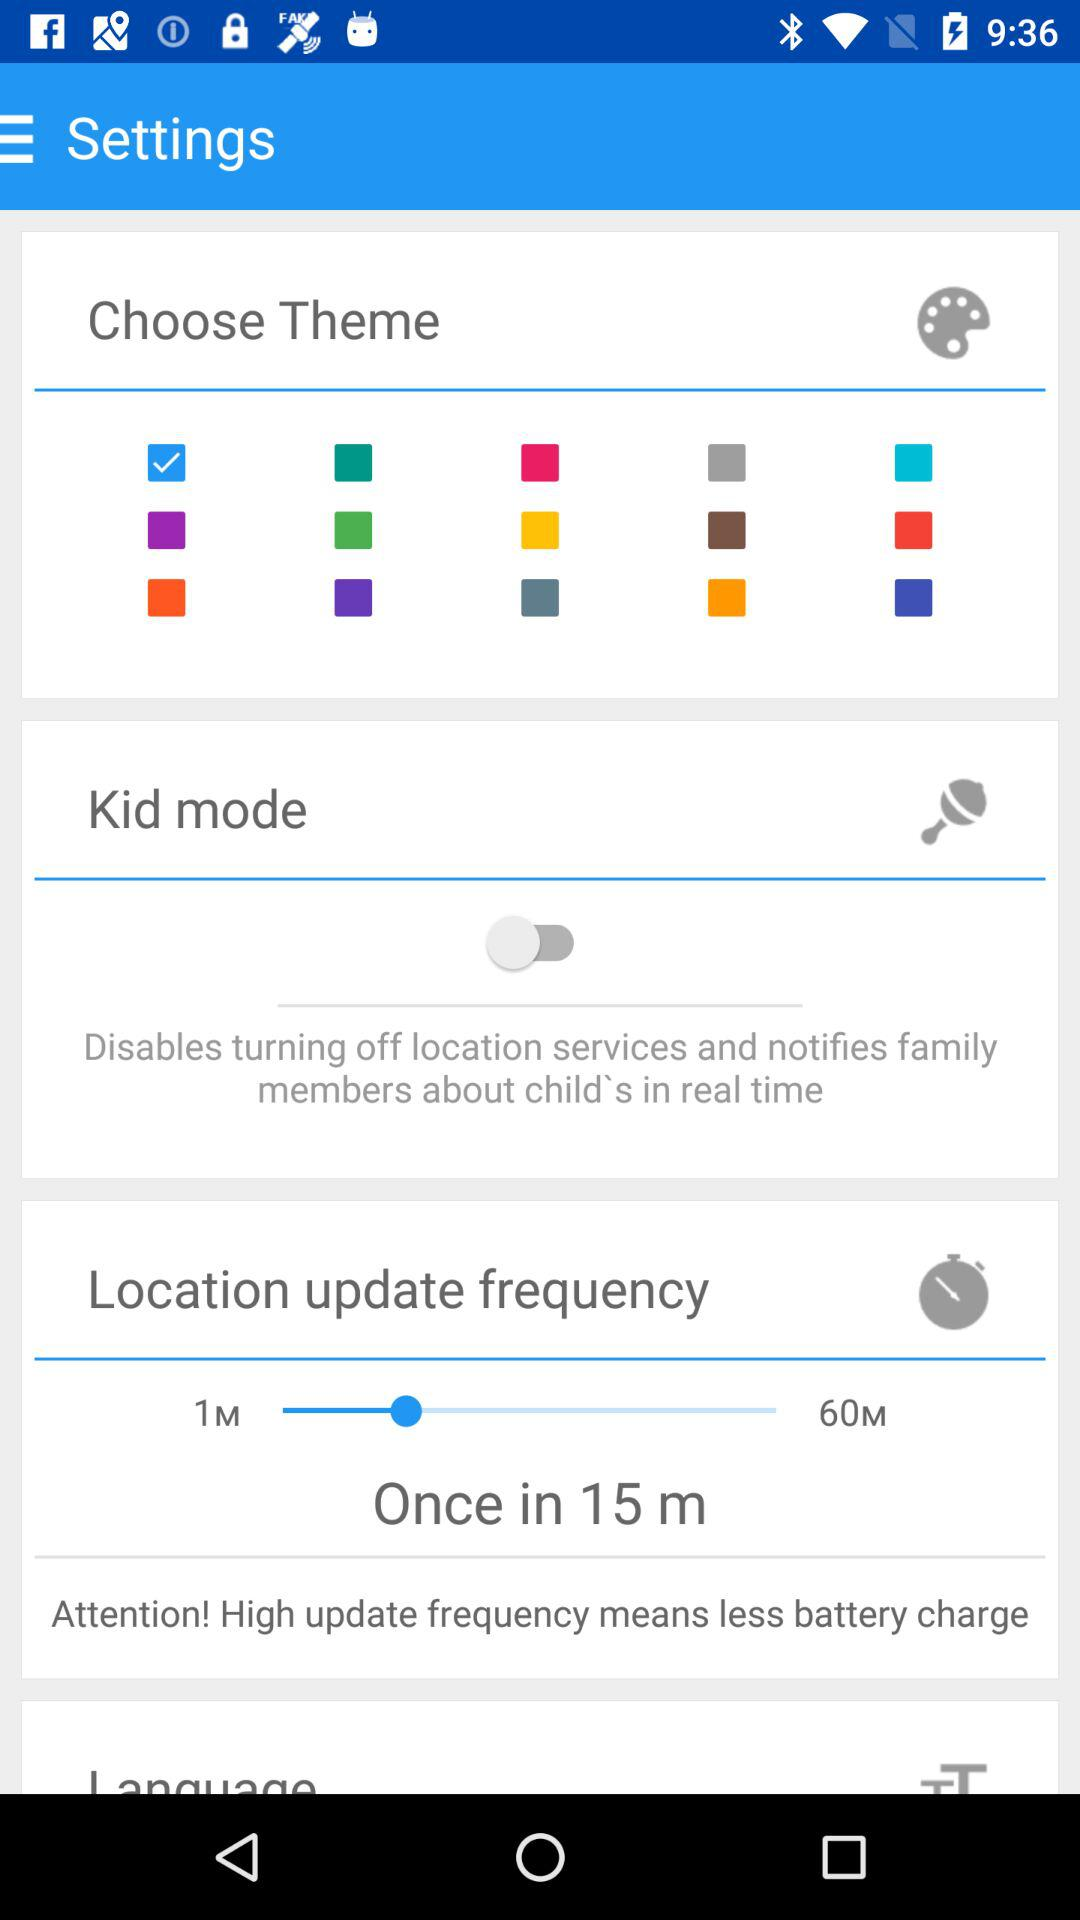What is the location update frequency? The location update frequency is once in 15 minutes. 